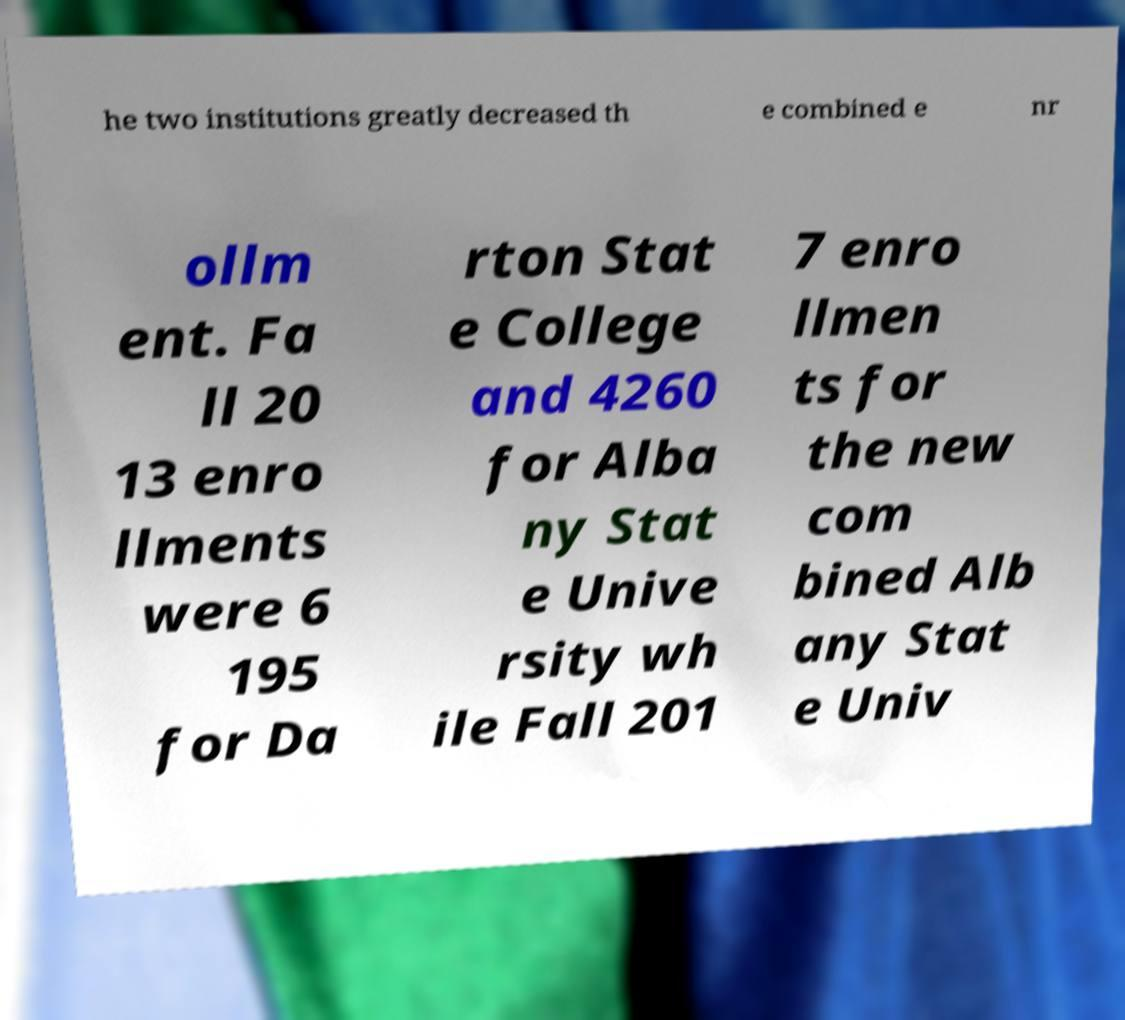Can you read and provide the text displayed in the image?This photo seems to have some interesting text. Can you extract and type it out for me? he two institutions greatly decreased th e combined e nr ollm ent. Fa ll 20 13 enro llments were 6 195 for Da rton Stat e College and 4260 for Alba ny Stat e Unive rsity wh ile Fall 201 7 enro llmen ts for the new com bined Alb any Stat e Univ 